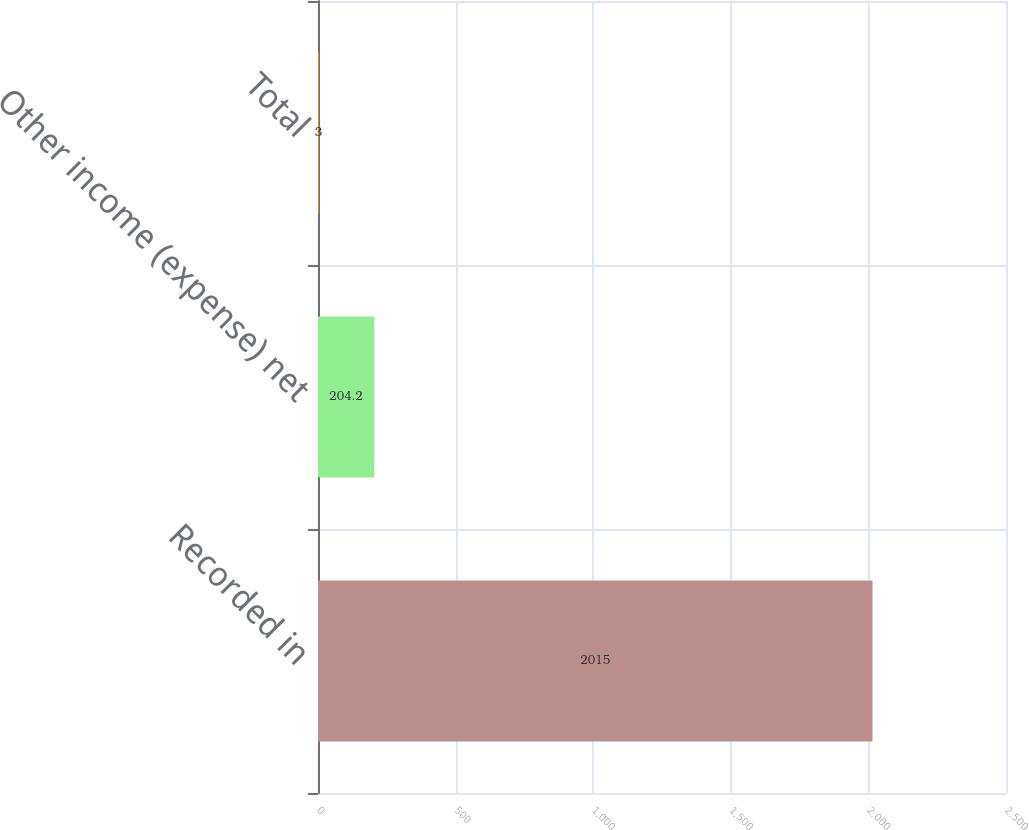<chart> <loc_0><loc_0><loc_500><loc_500><bar_chart><fcel>Recorded in<fcel>Other income (expense) net<fcel>Total<nl><fcel>2015<fcel>204.2<fcel>3<nl></chart> 